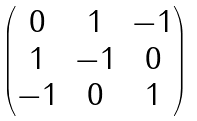Convert formula to latex. <formula><loc_0><loc_0><loc_500><loc_500>\begin{pmatrix} 0 & 1 & - 1 \\ 1 & - 1 & 0 \\ - 1 & 0 & 1 \end{pmatrix}</formula> 